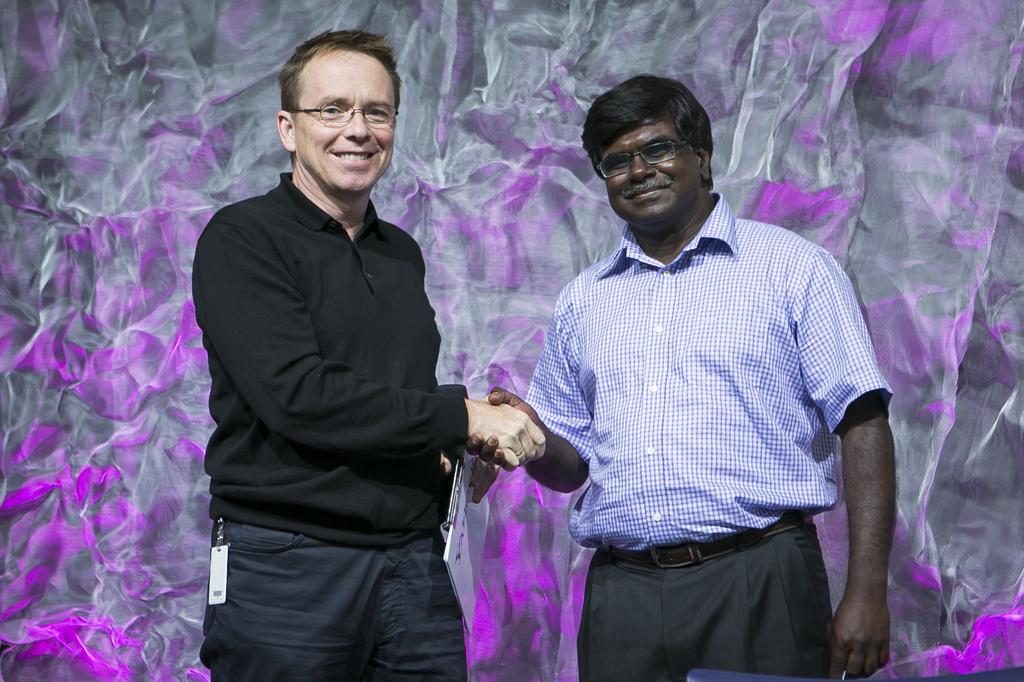How many people are in the image? There are two people standing in the image. What can be observed about the clothing of the people in the image? The people are wearing different color dresses. What is one person doing in the image? One person is holding something. What colors can be seen in the background of the image? The background of the image has purple and ash colors. Can you see any seashore or linen in the image? No, there is no seashore or linen present in the image. What type of pot is being used by one of the people in the image? There is no pot visible in the image; only the people and their dresses can be seen. 